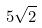Convert formula to latex. <formula><loc_0><loc_0><loc_500><loc_500>5 \sqrt { 2 }</formula> 